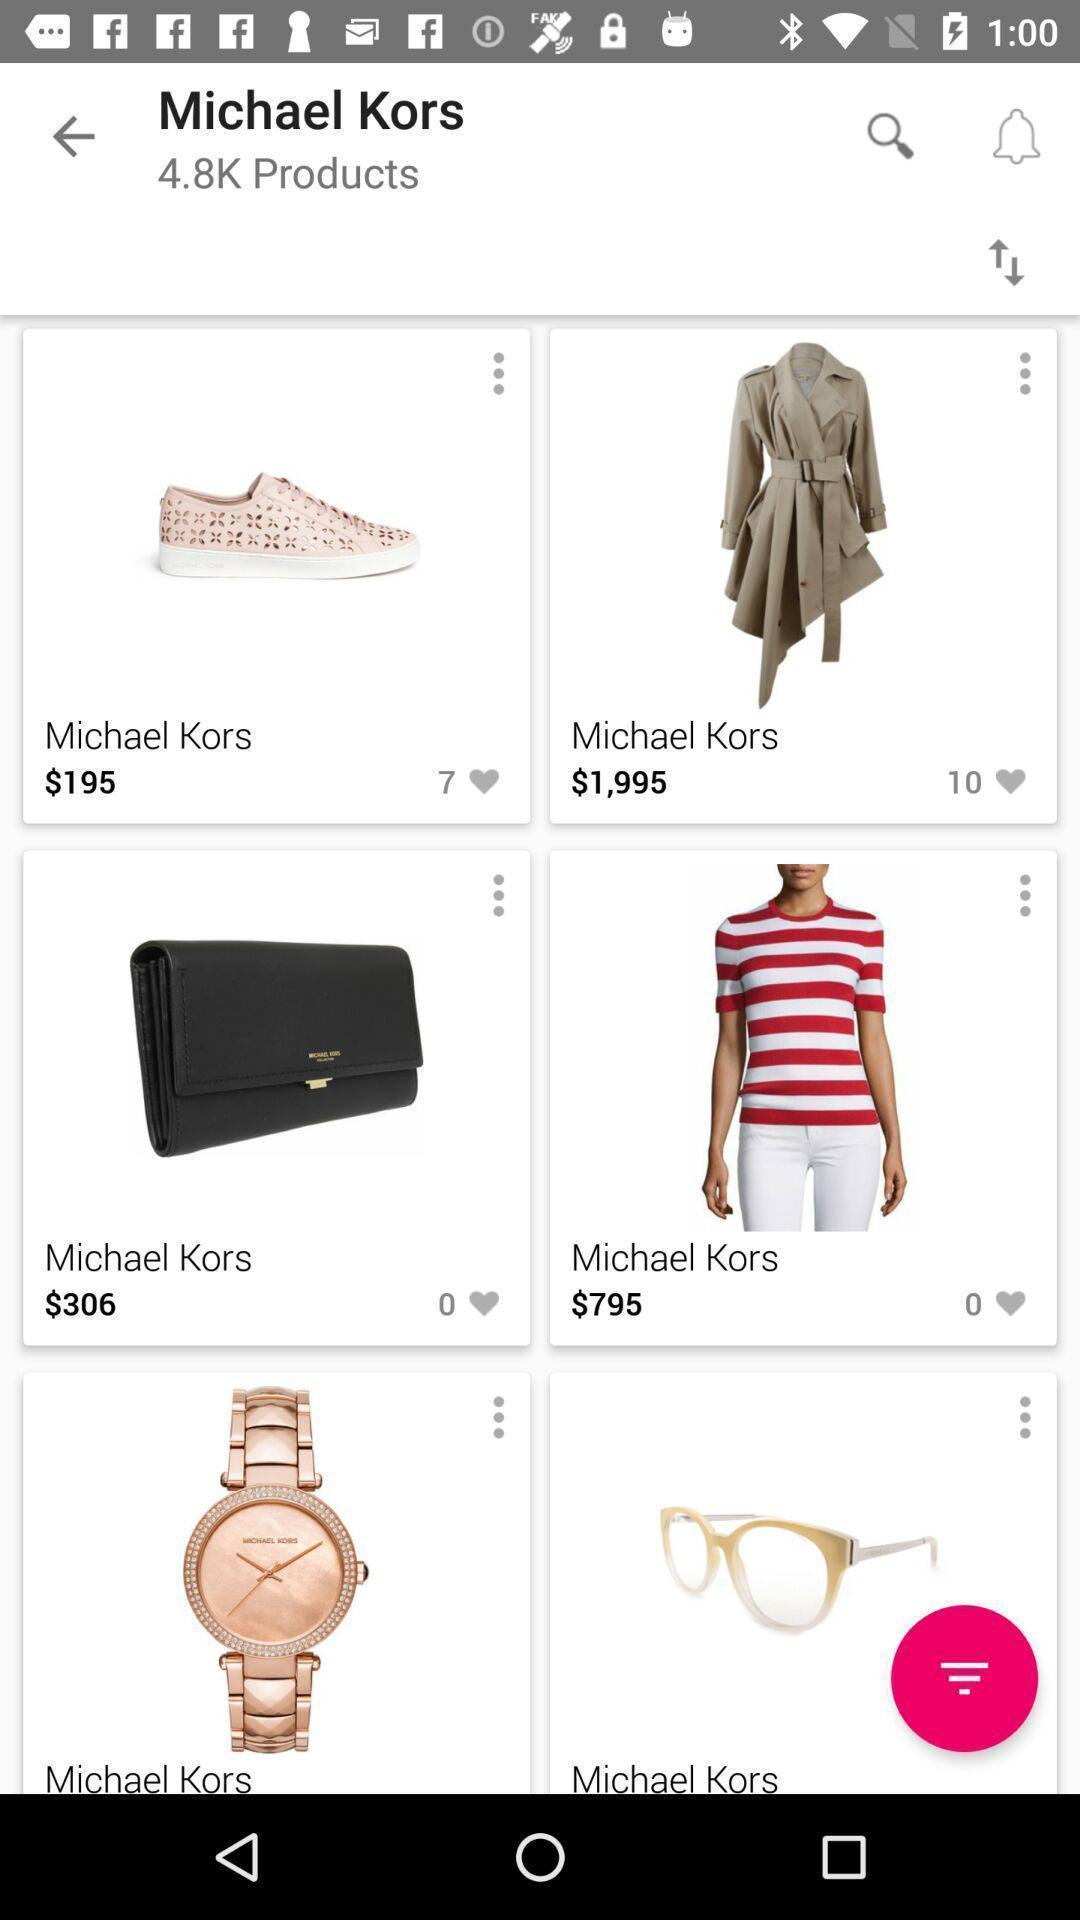Tell me about the visual elements in this screen capture. Page showing various products on a shopping app. 